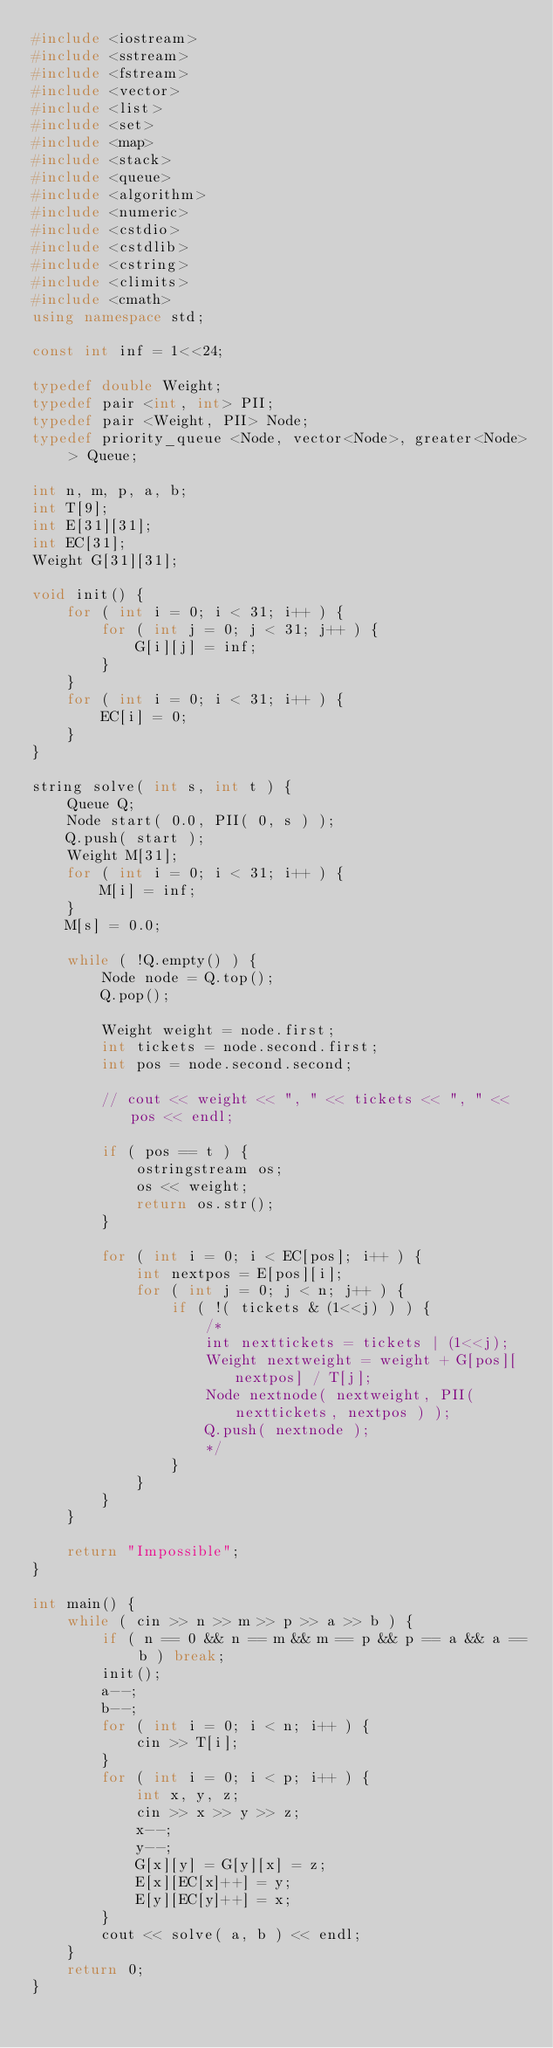<code> <loc_0><loc_0><loc_500><loc_500><_C++_>#include <iostream>
#include <sstream>
#include <fstream>
#include <vector>
#include <list>
#include <set>
#include <map>
#include <stack>
#include <queue>
#include <algorithm>
#include <numeric>
#include <cstdio>
#include <cstdlib>
#include <cstring>
#include <climits>
#include <cmath>
using namespace std;

const int inf = 1<<24;

typedef double Weight;
typedef pair <int, int> PII;
typedef pair <Weight, PII> Node;
typedef priority_queue <Node, vector<Node>, greater<Node> > Queue;

int n, m, p, a, b;
int T[9];
int E[31][31];
int EC[31];
Weight G[31][31];

void init() {
    for ( int i = 0; i < 31; i++ ) {
        for ( int j = 0; j < 31; j++ ) {
            G[i][j] = inf;
        }
    }
    for ( int i = 0; i < 31; i++ ) {
        EC[i] = 0;
    }
}

string solve( int s, int t ) {
    Queue Q;
    Node start( 0.0, PII( 0, s ) );
    Q.push( start );
    Weight M[31];
    for ( int i = 0; i < 31; i++ ) {
        M[i] = inf;
    }
    M[s] = 0.0;

    while ( !Q.empty() ) {
        Node node = Q.top();
        Q.pop();

        Weight weight = node.first;
        int tickets = node.second.first;
        int pos = node.second.second;

        // cout << weight << ", " << tickets << ", " << pos << endl;

        if ( pos == t ) {
            ostringstream os;
            os << weight;
            return os.str();
        }

        for ( int i = 0; i < EC[pos]; i++ ) {
            int nextpos = E[pos][i];
            for ( int j = 0; j < n; j++ ) {
                if ( !( tickets & (1<<j) ) ) {
                    /*
                    int nexttickets = tickets | (1<<j);
                    Weight nextweight = weight + G[pos][nextpos] / T[j];
                    Node nextnode( nextweight, PII( nexttickets, nextpos ) );
                    Q.push( nextnode );
                    */
                }
            }
        }
    }

    return "Impossible";
}

int main() {
    while ( cin >> n >> m >> p >> a >> b ) {
        if ( n == 0 && n == m && m == p && p == a && a == b ) break;
        init();
        a--;
        b--;
        for ( int i = 0; i < n; i++ ) {
            cin >> T[i];
        }
        for ( int i = 0; i < p; i++ ) {
            int x, y, z;
            cin >> x >> y >> z;
            x--;
            y--;
            G[x][y] = G[y][x] = z;
            E[x][EC[x]++] = y;
            E[y][EC[y]++] = x;
        }
        cout << solve( a, b ) << endl;
    }
    return 0;
}</code> 